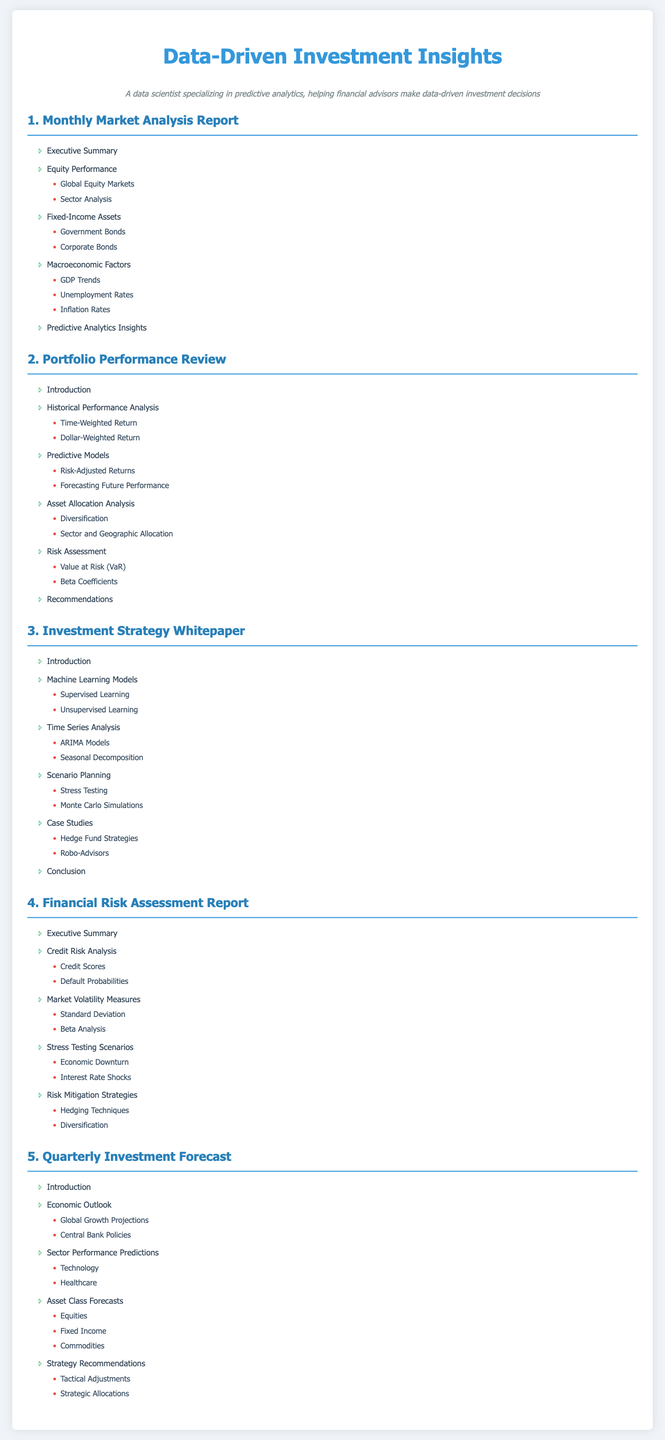What is the title of the first section? The title of the first section is listed in the document as "1. Monthly Market Analysis Report."
Answer: 1. Monthly Market Analysis Report How many subitems are there under Fixed-Income Assets? The document lists two subitems under "Fixed-Income Assets."
Answer: 2 What predictive model is mentioned in Portfolio Performance Review? "Predictive Models" section includes "Risk-Adjusted Returns" and "Forecasting Future Performance," but the specific predictive model is not named.
Answer: Risk-Adjusted Returns Which scenario planning method is included in the Investment Strategy Whitepaper? The "Investment Strategy Whitepaper" has "Scenario Planning" which lists two methods, one being "Stress Testing."
Answer: Stress Testing What does the Financial Risk Assessment Report evaluate? The main evaluation focus of the report is "Financial portfolios."
Answer: Financial portfolios How many main sections does the Quarterly Investment Forecast have? The Quarterly Investment Forecast consists of four main sections listed at the beginning of the table of contents.
Answer: 4 What is the focus of the first subitem under Equity Performance? The first subitem listed under Equity Performance is "Global Equity Markets."
Answer: Global Equity Markets Which two types of assets are discussed in the Quarterly Investment Forecast? The document mentions "Equities" and "Fixed Income" as types of assets discussed.
Answer: Equities and Fixed Income 